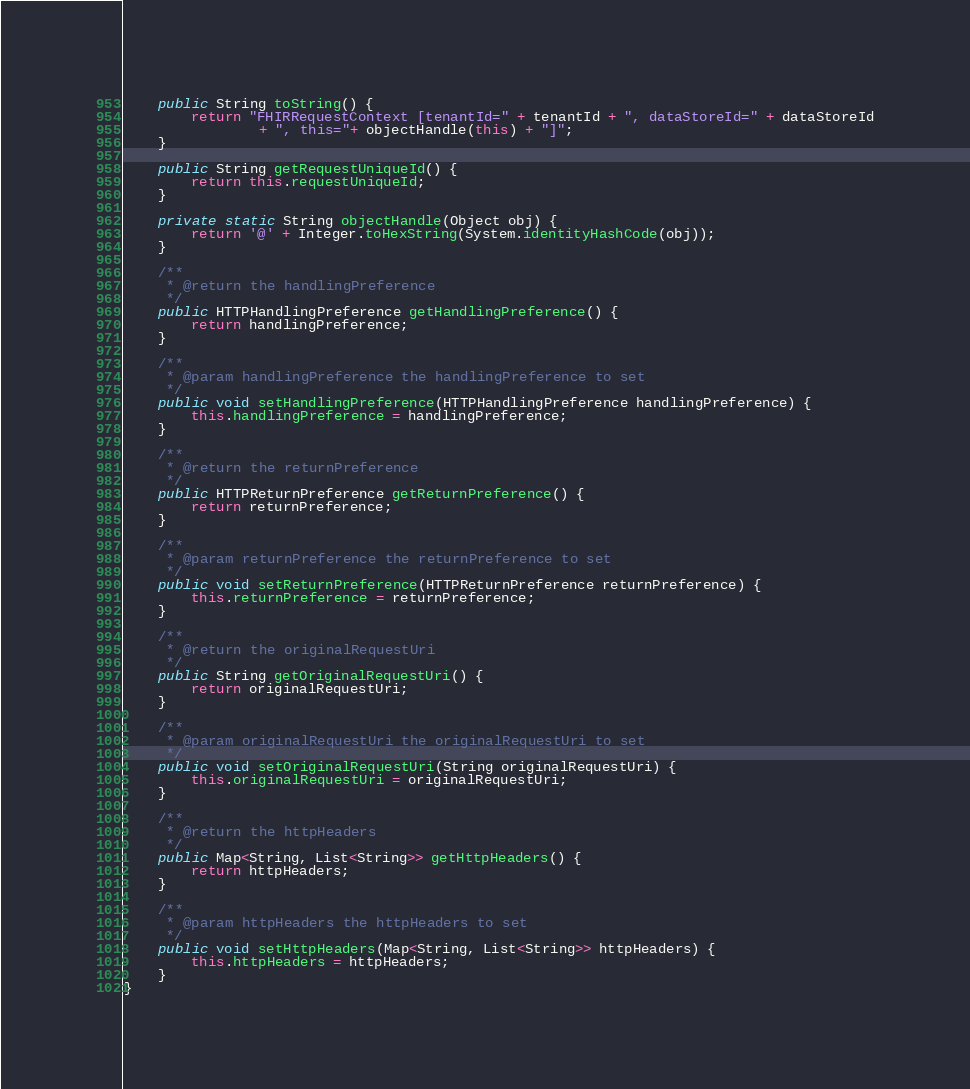Convert code to text. <code><loc_0><loc_0><loc_500><loc_500><_Java_>    public String toString() {
        return "FHIRRequestContext [tenantId=" + tenantId + ", dataStoreId=" + dataStoreId
                + ", this="+ objectHandle(this) + "]";
    }

    public String getRequestUniqueId() {
        return this.requestUniqueId;
    }

    private static String objectHandle(Object obj) {
        return '@' + Integer.toHexString(System.identityHashCode(obj));
    }

    /**
     * @return the handlingPreference
     */
    public HTTPHandlingPreference getHandlingPreference() {
        return handlingPreference;
    }

    /**
     * @param handlingPreference the handlingPreference to set
     */
    public void setHandlingPreference(HTTPHandlingPreference handlingPreference) {
        this.handlingPreference = handlingPreference;
    }

    /**
     * @return the returnPreference
     */
    public HTTPReturnPreference getReturnPreference() {
        return returnPreference;
    }

    /**
     * @param returnPreference the returnPreference to set
     */
    public void setReturnPreference(HTTPReturnPreference returnPreference) {
        this.returnPreference = returnPreference;
    }

    /**
     * @return the originalRequestUri
     */
    public String getOriginalRequestUri() {
        return originalRequestUri;
    }

    /**
     * @param originalRequestUri the originalRequestUri to set
     */
    public void setOriginalRequestUri(String originalRequestUri) {
        this.originalRequestUri = originalRequestUri;
    }

    /**
     * @return the httpHeaders
     */
    public Map<String, List<String>> getHttpHeaders() {
        return httpHeaders;
    }

    /**
     * @param httpHeaders the httpHeaders to set
     */
    public void setHttpHeaders(Map<String, List<String>> httpHeaders) {
        this.httpHeaders = httpHeaders;
    }
}
</code> 